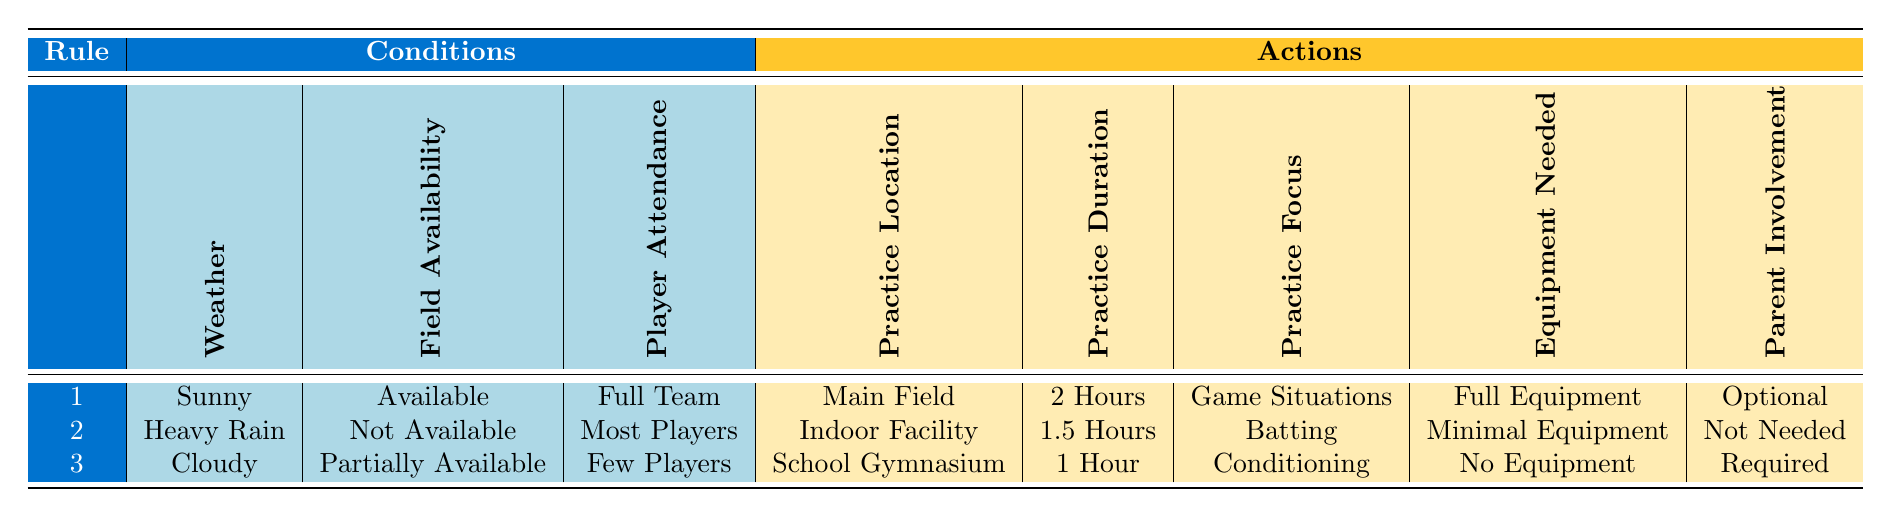What is the practice location for a sunny day with full team attendance? According to rule 1 in the table, on a sunny day, when the field is available and there is full team attendance, the practice location is designated as the Main Field.
Answer: Main Field How long is the practice duration when there is heavy rain and most players are present? Looking at rule 2, during heavy rain, if the field is not available but most players are present, the practice duration is set for 1.5 hours.
Answer: 1.5 Hours Is parent involvement needed for practice under cloudy conditions with few players? From rule 3, we can see that when it's cloudy and only a few players are available, parent involvement is required.
Answer: Yes What is the average practice duration across all rules? The practice durations listed are 2 hours, 1.5 hours, and 1 hour. Adding these values gives (2 + 1.5 + 1) = 4.5 hours. Dividing by the number of rules (3), the average is 4.5/3 = 1.5 hours.
Answer: 1.5 Hours Can practice take place at the Main Field if it is cloudy? Referring to the conditions from the table, under cloudy conditions (such as rule 3), the practice location is the School Gymnasium, implying that the Main Field is not available for practice during cloudy weather.
Answer: No Under what conditions is batting focused during practice? In rule 2, practice focuses on batting when it is heavy rain, the field is not available, there are most players present, during the evening, and the upcoming game is within a week.
Answer: Heavy Rain, Not Available, Most Players, Evening, Within a Week What equipment is needed for practice if there are few players on a cloudy day? According to rule 3, with cloudy weather and few players, the required equipment is stated as "No Equipment."
Answer: No Equipment If the upcoming game is more than a week away and it's sunny, what is the practice focus? The table does not specify a practice focus for a sunny day with more than a week until the game since none of the rules cover this combination, indicating that practice might not be scheduled under these specific circumstances.
Answer: Unknown 